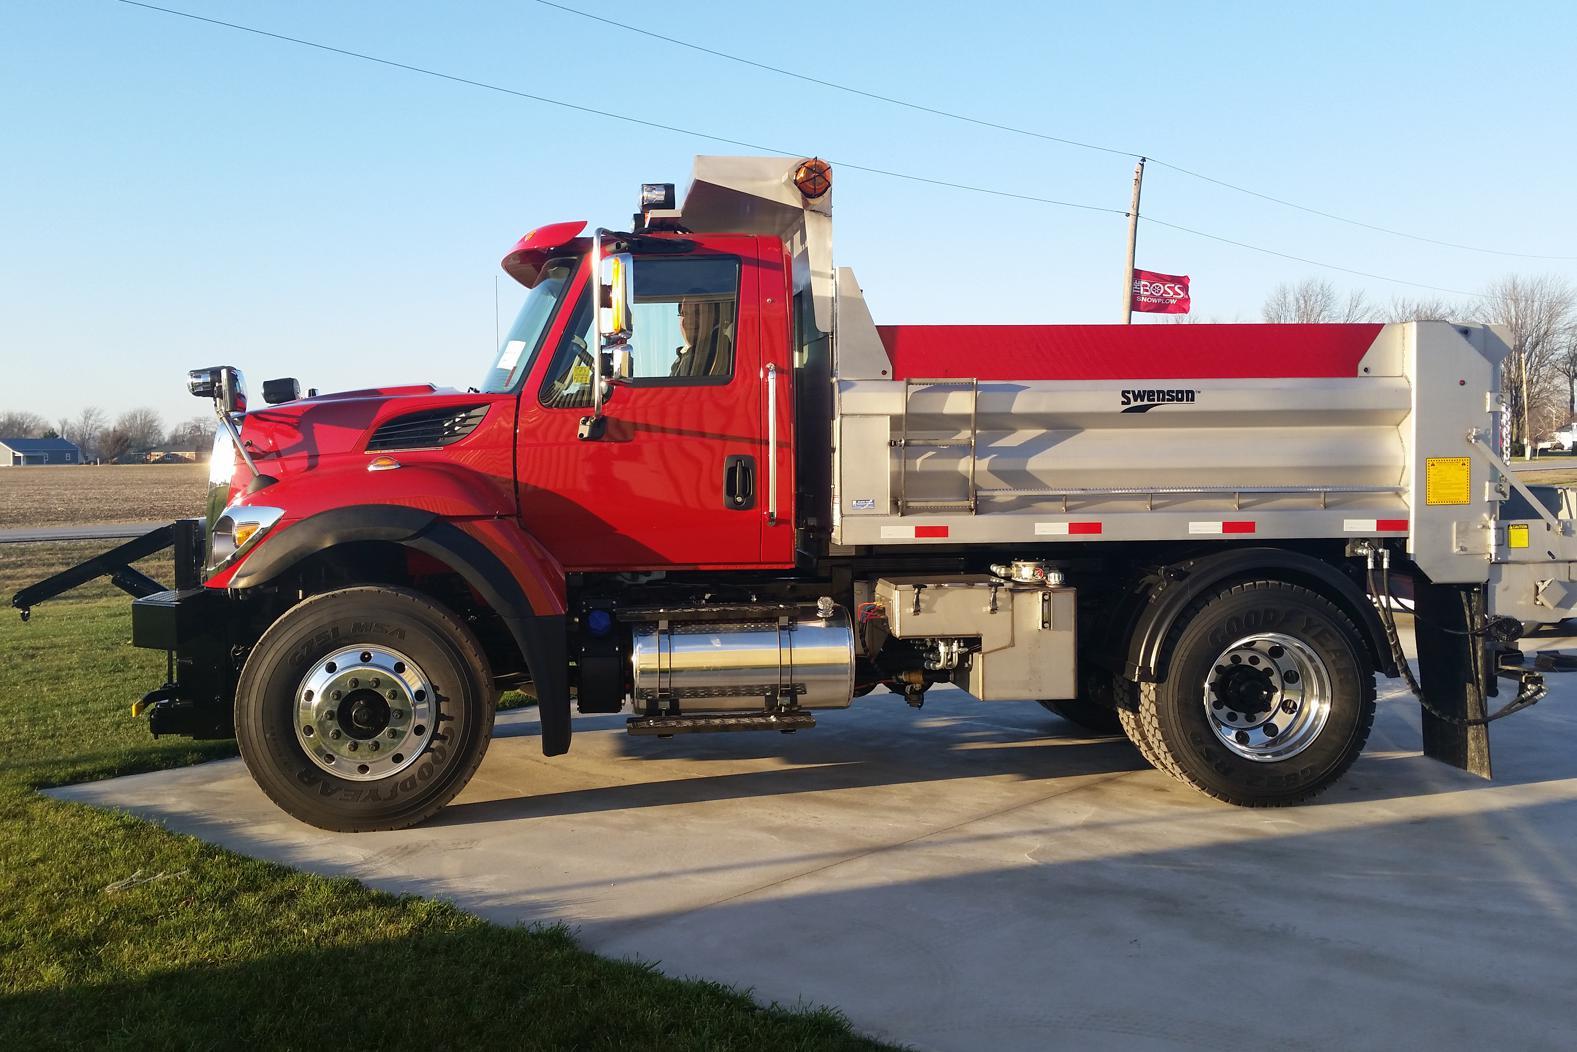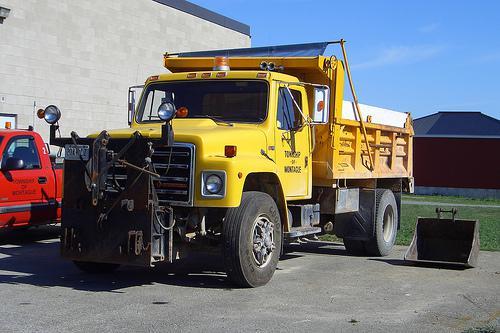The first image is the image on the left, the second image is the image on the right. Examine the images to the left and right. Is the description "All trucks have attached shovels." accurate? Answer yes or no. No. 